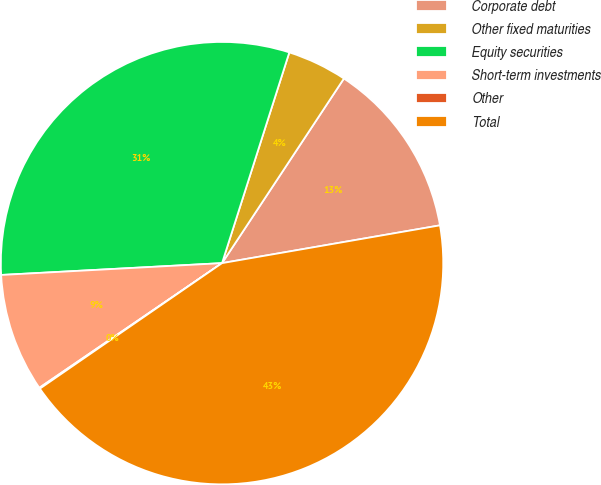Convert chart. <chart><loc_0><loc_0><loc_500><loc_500><pie_chart><fcel>Corporate debt<fcel>Other fixed maturities<fcel>Equity securities<fcel>Short-term investments<fcel>Other<fcel>Total<nl><fcel>12.98%<fcel>4.37%<fcel>30.77%<fcel>8.68%<fcel>0.07%<fcel>43.13%<nl></chart> 